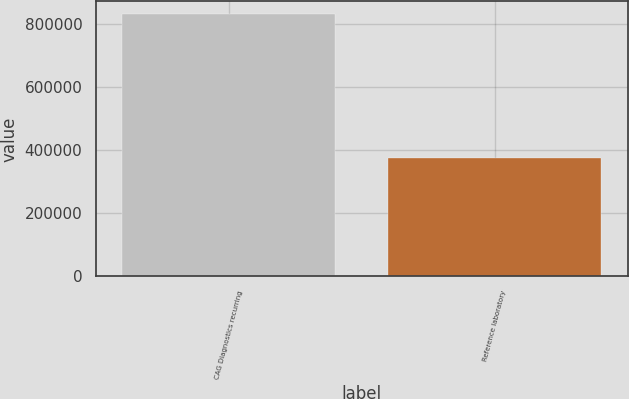Convert chart to OTSL. <chart><loc_0><loc_0><loc_500><loc_500><bar_chart><fcel>CAG Diagnostics recurring<fcel>Reference laboratory<nl><fcel>829192<fcel>373919<nl></chart> 